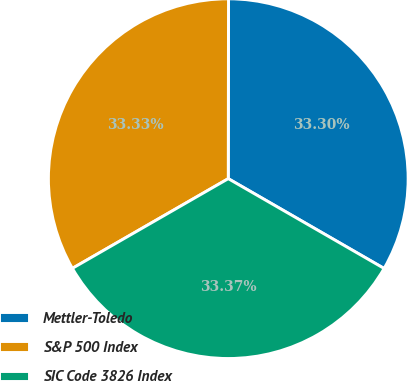Convert chart. <chart><loc_0><loc_0><loc_500><loc_500><pie_chart><fcel>Mettler-Toledo<fcel>S&P 500 Index<fcel>SIC Code 3826 Index<nl><fcel>33.3%<fcel>33.33%<fcel>33.37%<nl></chart> 